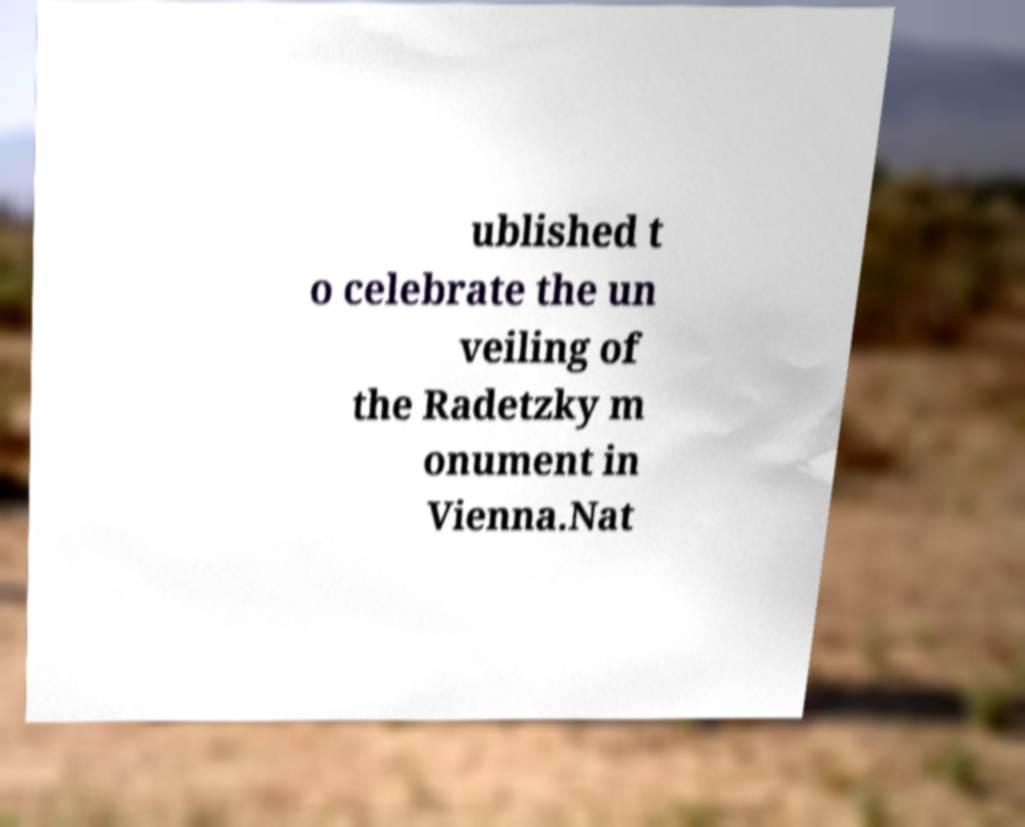Could you assist in decoding the text presented in this image and type it out clearly? ublished t o celebrate the un veiling of the Radetzky m onument in Vienna.Nat 